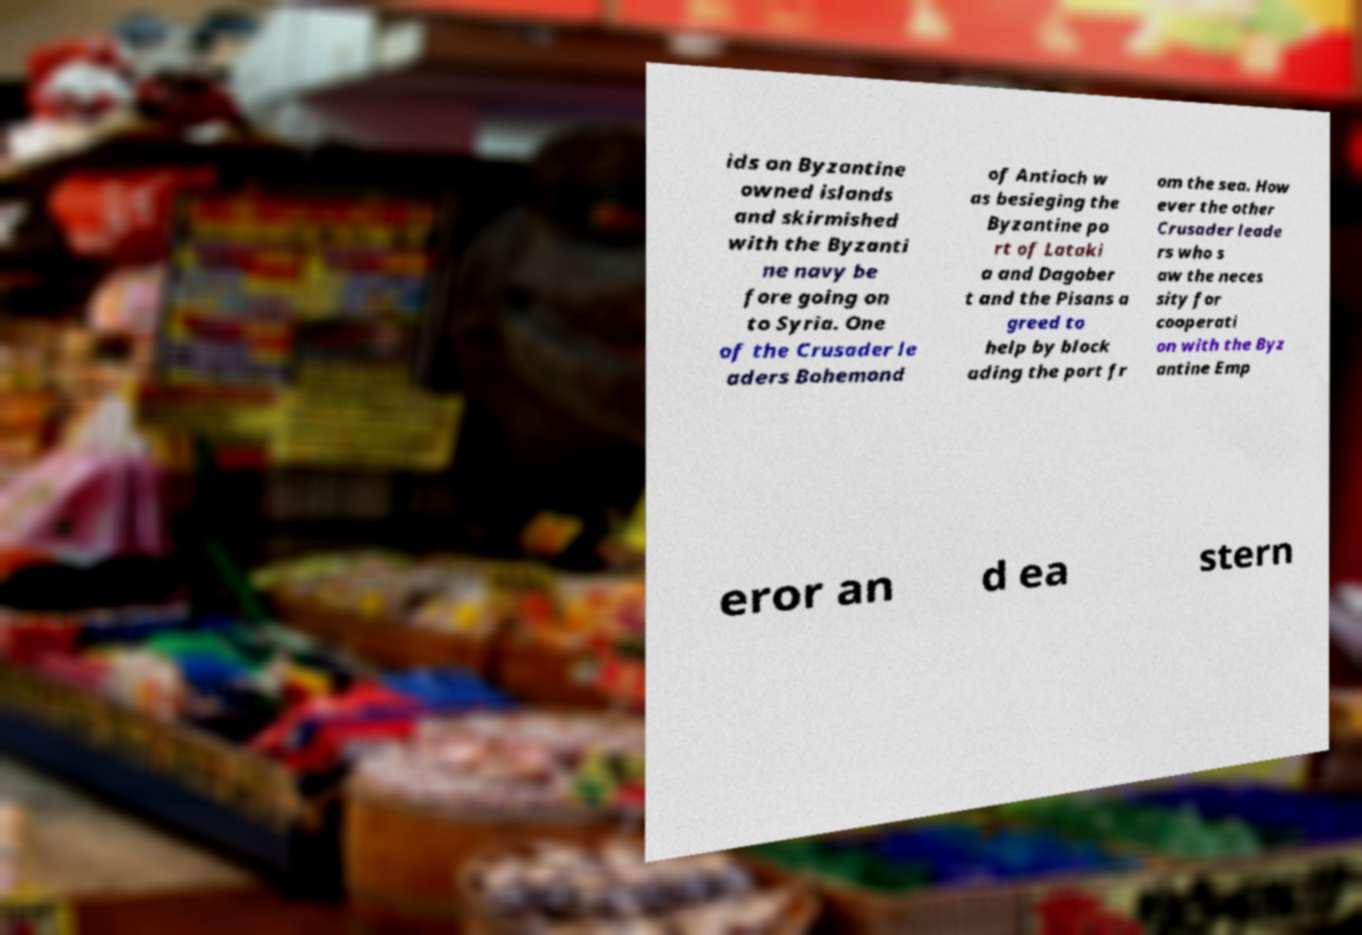I need the written content from this picture converted into text. Can you do that? ids on Byzantine owned islands and skirmished with the Byzanti ne navy be fore going on to Syria. One of the Crusader le aders Bohemond of Antioch w as besieging the Byzantine po rt of Lataki a and Dagober t and the Pisans a greed to help by block ading the port fr om the sea. How ever the other Crusader leade rs who s aw the neces sity for cooperati on with the Byz antine Emp eror an d ea stern 